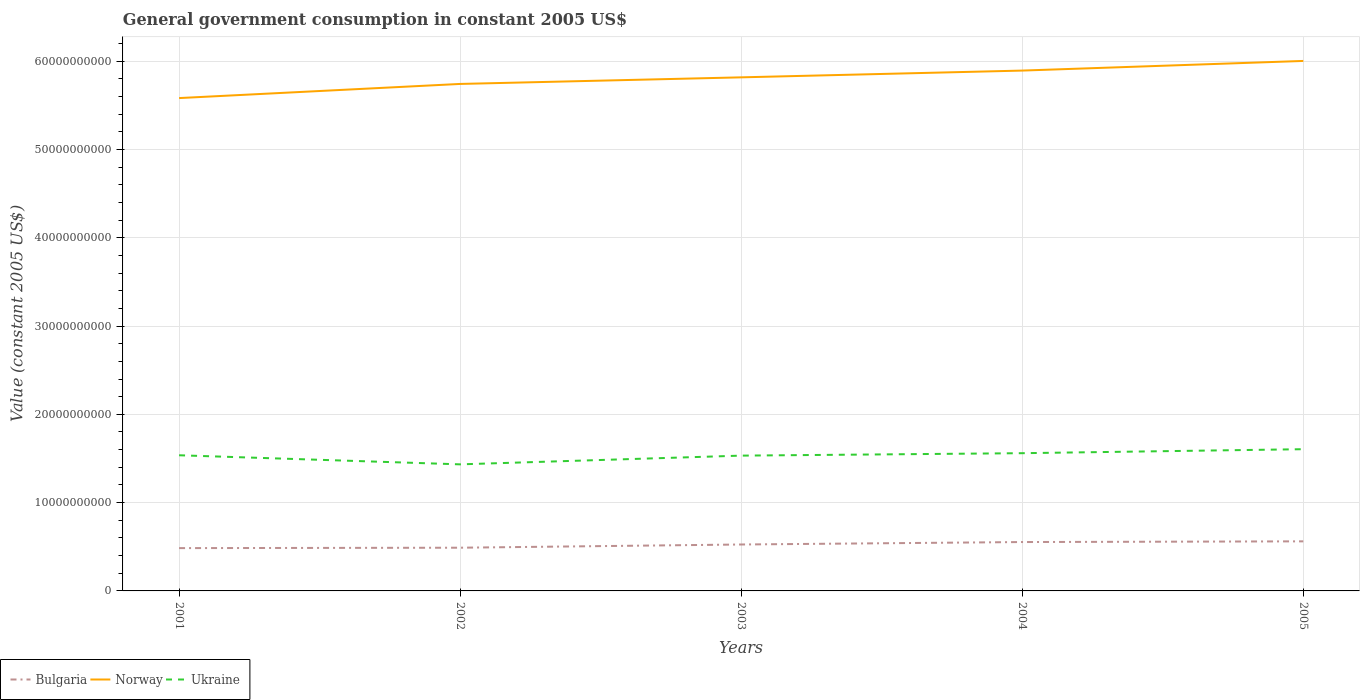How many different coloured lines are there?
Make the answer very short. 3. Does the line corresponding to Norway intersect with the line corresponding to Bulgaria?
Provide a short and direct response. No. Is the number of lines equal to the number of legend labels?
Provide a short and direct response. Yes. Across all years, what is the maximum government conusmption in Bulgaria?
Offer a very short reply. 4.85e+09. In which year was the government conusmption in Norway maximum?
Offer a terse response. 2001. What is the total government conusmption in Bulgaria in the graph?
Provide a succinct answer. -6.42e+08. What is the difference between the highest and the second highest government conusmption in Bulgaria?
Provide a succinct answer. 7.66e+08. What is the difference between the highest and the lowest government conusmption in Ukraine?
Give a very brief answer. 3. Is the government conusmption in Bulgaria strictly greater than the government conusmption in Norway over the years?
Provide a succinct answer. Yes. How many lines are there?
Your response must be concise. 3. How many years are there in the graph?
Give a very brief answer. 5. Are the values on the major ticks of Y-axis written in scientific E-notation?
Offer a very short reply. No. Does the graph contain any zero values?
Provide a short and direct response. No. Does the graph contain grids?
Make the answer very short. Yes. How many legend labels are there?
Your answer should be very brief. 3. What is the title of the graph?
Provide a succinct answer. General government consumption in constant 2005 US$. What is the label or title of the Y-axis?
Provide a short and direct response. Value (constant 2005 US$). What is the Value (constant 2005 US$) in Bulgaria in 2001?
Offer a very short reply. 4.85e+09. What is the Value (constant 2005 US$) in Norway in 2001?
Offer a terse response. 5.58e+1. What is the Value (constant 2005 US$) of Ukraine in 2001?
Provide a short and direct response. 1.54e+1. What is the Value (constant 2005 US$) of Bulgaria in 2002?
Your answer should be compact. 4.89e+09. What is the Value (constant 2005 US$) of Norway in 2002?
Make the answer very short. 5.74e+1. What is the Value (constant 2005 US$) of Ukraine in 2002?
Make the answer very short. 1.43e+1. What is the Value (constant 2005 US$) of Bulgaria in 2003?
Offer a very short reply. 5.26e+09. What is the Value (constant 2005 US$) in Norway in 2003?
Give a very brief answer. 5.82e+1. What is the Value (constant 2005 US$) in Ukraine in 2003?
Your answer should be very brief. 1.53e+1. What is the Value (constant 2005 US$) of Bulgaria in 2004?
Provide a succinct answer. 5.54e+09. What is the Value (constant 2005 US$) in Norway in 2004?
Provide a short and direct response. 5.89e+1. What is the Value (constant 2005 US$) of Ukraine in 2004?
Give a very brief answer. 1.56e+1. What is the Value (constant 2005 US$) of Bulgaria in 2005?
Provide a succinct answer. 5.61e+09. What is the Value (constant 2005 US$) of Norway in 2005?
Offer a very short reply. 6.00e+1. What is the Value (constant 2005 US$) in Ukraine in 2005?
Give a very brief answer. 1.61e+1. Across all years, what is the maximum Value (constant 2005 US$) in Bulgaria?
Ensure brevity in your answer.  5.61e+09. Across all years, what is the maximum Value (constant 2005 US$) of Norway?
Offer a terse response. 6.00e+1. Across all years, what is the maximum Value (constant 2005 US$) in Ukraine?
Ensure brevity in your answer.  1.61e+1. Across all years, what is the minimum Value (constant 2005 US$) in Bulgaria?
Offer a very short reply. 4.85e+09. Across all years, what is the minimum Value (constant 2005 US$) in Norway?
Provide a short and direct response. 5.58e+1. Across all years, what is the minimum Value (constant 2005 US$) in Ukraine?
Provide a short and direct response. 1.43e+1. What is the total Value (constant 2005 US$) of Bulgaria in the graph?
Provide a short and direct response. 2.62e+1. What is the total Value (constant 2005 US$) in Norway in the graph?
Provide a short and direct response. 2.90e+11. What is the total Value (constant 2005 US$) in Ukraine in the graph?
Make the answer very short. 7.67e+1. What is the difference between the Value (constant 2005 US$) of Bulgaria in 2001 and that in 2002?
Your response must be concise. -4.58e+07. What is the difference between the Value (constant 2005 US$) in Norway in 2001 and that in 2002?
Offer a terse response. -1.60e+09. What is the difference between the Value (constant 2005 US$) in Ukraine in 2001 and that in 2002?
Make the answer very short. 1.03e+09. What is the difference between the Value (constant 2005 US$) of Bulgaria in 2001 and that in 2003?
Your answer should be very brief. -4.10e+08. What is the difference between the Value (constant 2005 US$) in Norway in 2001 and that in 2003?
Offer a terse response. -2.35e+09. What is the difference between the Value (constant 2005 US$) in Ukraine in 2001 and that in 2003?
Offer a terse response. 4.03e+07. What is the difference between the Value (constant 2005 US$) of Bulgaria in 2001 and that in 2004?
Give a very brief answer. -6.88e+08. What is the difference between the Value (constant 2005 US$) of Norway in 2001 and that in 2004?
Offer a terse response. -3.11e+09. What is the difference between the Value (constant 2005 US$) of Ukraine in 2001 and that in 2004?
Your answer should be compact. -2.36e+08. What is the difference between the Value (constant 2005 US$) in Bulgaria in 2001 and that in 2005?
Ensure brevity in your answer.  -7.66e+08. What is the difference between the Value (constant 2005 US$) in Norway in 2001 and that in 2005?
Offer a terse response. -4.21e+09. What is the difference between the Value (constant 2005 US$) in Ukraine in 2001 and that in 2005?
Offer a very short reply. -6.88e+08. What is the difference between the Value (constant 2005 US$) in Bulgaria in 2002 and that in 2003?
Provide a short and direct response. -3.64e+08. What is the difference between the Value (constant 2005 US$) of Norway in 2002 and that in 2003?
Keep it short and to the point. -7.47e+08. What is the difference between the Value (constant 2005 US$) in Ukraine in 2002 and that in 2003?
Offer a very short reply. -9.89e+08. What is the difference between the Value (constant 2005 US$) in Bulgaria in 2002 and that in 2004?
Provide a short and direct response. -6.42e+08. What is the difference between the Value (constant 2005 US$) of Norway in 2002 and that in 2004?
Your answer should be compact. -1.51e+09. What is the difference between the Value (constant 2005 US$) of Ukraine in 2002 and that in 2004?
Offer a very short reply. -1.26e+09. What is the difference between the Value (constant 2005 US$) of Bulgaria in 2002 and that in 2005?
Give a very brief answer. -7.21e+08. What is the difference between the Value (constant 2005 US$) of Norway in 2002 and that in 2005?
Ensure brevity in your answer.  -2.61e+09. What is the difference between the Value (constant 2005 US$) of Ukraine in 2002 and that in 2005?
Ensure brevity in your answer.  -1.72e+09. What is the difference between the Value (constant 2005 US$) of Bulgaria in 2003 and that in 2004?
Keep it short and to the point. -2.78e+08. What is the difference between the Value (constant 2005 US$) in Norway in 2003 and that in 2004?
Give a very brief answer. -7.66e+08. What is the difference between the Value (constant 2005 US$) of Ukraine in 2003 and that in 2004?
Offer a terse response. -2.76e+08. What is the difference between the Value (constant 2005 US$) of Bulgaria in 2003 and that in 2005?
Provide a succinct answer. -3.56e+08. What is the difference between the Value (constant 2005 US$) of Norway in 2003 and that in 2005?
Offer a terse response. -1.86e+09. What is the difference between the Value (constant 2005 US$) of Ukraine in 2003 and that in 2005?
Your answer should be compact. -7.28e+08. What is the difference between the Value (constant 2005 US$) in Bulgaria in 2004 and that in 2005?
Make the answer very short. -7.82e+07. What is the difference between the Value (constant 2005 US$) of Norway in 2004 and that in 2005?
Your answer should be very brief. -1.09e+09. What is the difference between the Value (constant 2005 US$) in Ukraine in 2004 and that in 2005?
Offer a very short reply. -4.52e+08. What is the difference between the Value (constant 2005 US$) of Bulgaria in 2001 and the Value (constant 2005 US$) of Norway in 2002?
Offer a very short reply. -5.26e+1. What is the difference between the Value (constant 2005 US$) of Bulgaria in 2001 and the Value (constant 2005 US$) of Ukraine in 2002?
Provide a succinct answer. -9.49e+09. What is the difference between the Value (constant 2005 US$) in Norway in 2001 and the Value (constant 2005 US$) in Ukraine in 2002?
Provide a succinct answer. 4.15e+1. What is the difference between the Value (constant 2005 US$) of Bulgaria in 2001 and the Value (constant 2005 US$) of Norway in 2003?
Your answer should be compact. -5.33e+1. What is the difference between the Value (constant 2005 US$) in Bulgaria in 2001 and the Value (constant 2005 US$) in Ukraine in 2003?
Ensure brevity in your answer.  -1.05e+1. What is the difference between the Value (constant 2005 US$) of Norway in 2001 and the Value (constant 2005 US$) of Ukraine in 2003?
Your answer should be compact. 4.05e+1. What is the difference between the Value (constant 2005 US$) of Bulgaria in 2001 and the Value (constant 2005 US$) of Norway in 2004?
Offer a very short reply. -5.41e+1. What is the difference between the Value (constant 2005 US$) in Bulgaria in 2001 and the Value (constant 2005 US$) in Ukraine in 2004?
Offer a very short reply. -1.08e+1. What is the difference between the Value (constant 2005 US$) of Norway in 2001 and the Value (constant 2005 US$) of Ukraine in 2004?
Offer a terse response. 4.02e+1. What is the difference between the Value (constant 2005 US$) in Bulgaria in 2001 and the Value (constant 2005 US$) in Norway in 2005?
Your response must be concise. -5.52e+1. What is the difference between the Value (constant 2005 US$) in Bulgaria in 2001 and the Value (constant 2005 US$) in Ukraine in 2005?
Your response must be concise. -1.12e+1. What is the difference between the Value (constant 2005 US$) in Norway in 2001 and the Value (constant 2005 US$) in Ukraine in 2005?
Ensure brevity in your answer.  3.98e+1. What is the difference between the Value (constant 2005 US$) of Bulgaria in 2002 and the Value (constant 2005 US$) of Norway in 2003?
Make the answer very short. -5.33e+1. What is the difference between the Value (constant 2005 US$) of Bulgaria in 2002 and the Value (constant 2005 US$) of Ukraine in 2003?
Offer a terse response. -1.04e+1. What is the difference between the Value (constant 2005 US$) of Norway in 2002 and the Value (constant 2005 US$) of Ukraine in 2003?
Your response must be concise. 4.21e+1. What is the difference between the Value (constant 2005 US$) in Bulgaria in 2002 and the Value (constant 2005 US$) in Norway in 2004?
Provide a short and direct response. -5.40e+1. What is the difference between the Value (constant 2005 US$) in Bulgaria in 2002 and the Value (constant 2005 US$) in Ukraine in 2004?
Your answer should be compact. -1.07e+1. What is the difference between the Value (constant 2005 US$) of Norway in 2002 and the Value (constant 2005 US$) of Ukraine in 2004?
Provide a succinct answer. 4.18e+1. What is the difference between the Value (constant 2005 US$) in Bulgaria in 2002 and the Value (constant 2005 US$) in Norway in 2005?
Provide a short and direct response. -5.51e+1. What is the difference between the Value (constant 2005 US$) in Bulgaria in 2002 and the Value (constant 2005 US$) in Ukraine in 2005?
Your response must be concise. -1.12e+1. What is the difference between the Value (constant 2005 US$) of Norway in 2002 and the Value (constant 2005 US$) of Ukraine in 2005?
Your answer should be compact. 4.14e+1. What is the difference between the Value (constant 2005 US$) in Bulgaria in 2003 and the Value (constant 2005 US$) in Norway in 2004?
Ensure brevity in your answer.  -5.37e+1. What is the difference between the Value (constant 2005 US$) of Bulgaria in 2003 and the Value (constant 2005 US$) of Ukraine in 2004?
Ensure brevity in your answer.  -1.03e+1. What is the difference between the Value (constant 2005 US$) of Norway in 2003 and the Value (constant 2005 US$) of Ukraine in 2004?
Your answer should be very brief. 4.26e+1. What is the difference between the Value (constant 2005 US$) of Bulgaria in 2003 and the Value (constant 2005 US$) of Norway in 2005?
Offer a terse response. -5.48e+1. What is the difference between the Value (constant 2005 US$) of Bulgaria in 2003 and the Value (constant 2005 US$) of Ukraine in 2005?
Offer a terse response. -1.08e+1. What is the difference between the Value (constant 2005 US$) of Norway in 2003 and the Value (constant 2005 US$) of Ukraine in 2005?
Your answer should be compact. 4.21e+1. What is the difference between the Value (constant 2005 US$) in Bulgaria in 2004 and the Value (constant 2005 US$) in Norway in 2005?
Ensure brevity in your answer.  -5.45e+1. What is the difference between the Value (constant 2005 US$) of Bulgaria in 2004 and the Value (constant 2005 US$) of Ukraine in 2005?
Give a very brief answer. -1.05e+1. What is the difference between the Value (constant 2005 US$) in Norway in 2004 and the Value (constant 2005 US$) in Ukraine in 2005?
Provide a succinct answer. 4.29e+1. What is the average Value (constant 2005 US$) of Bulgaria per year?
Provide a succinct answer. 5.23e+09. What is the average Value (constant 2005 US$) of Norway per year?
Provide a succinct answer. 5.81e+1. What is the average Value (constant 2005 US$) in Ukraine per year?
Provide a short and direct response. 1.53e+1. In the year 2001, what is the difference between the Value (constant 2005 US$) of Bulgaria and Value (constant 2005 US$) of Norway?
Keep it short and to the point. -5.10e+1. In the year 2001, what is the difference between the Value (constant 2005 US$) of Bulgaria and Value (constant 2005 US$) of Ukraine?
Make the answer very short. -1.05e+1. In the year 2001, what is the difference between the Value (constant 2005 US$) of Norway and Value (constant 2005 US$) of Ukraine?
Offer a terse response. 4.05e+1. In the year 2002, what is the difference between the Value (constant 2005 US$) of Bulgaria and Value (constant 2005 US$) of Norway?
Offer a very short reply. -5.25e+1. In the year 2002, what is the difference between the Value (constant 2005 US$) in Bulgaria and Value (constant 2005 US$) in Ukraine?
Your answer should be compact. -9.44e+09. In the year 2002, what is the difference between the Value (constant 2005 US$) of Norway and Value (constant 2005 US$) of Ukraine?
Provide a succinct answer. 4.31e+1. In the year 2003, what is the difference between the Value (constant 2005 US$) in Bulgaria and Value (constant 2005 US$) in Norway?
Ensure brevity in your answer.  -5.29e+1. In the year 2003, what is the difference between the Value (constant 2005 US$) in Bulgaria and Value (constant 2005 US$) in Ukraine?
Provide a succinct answer. -1.01e+1. In the year 2003, what is the difference between the Value (constant 2005 US$) of Norway and Value (constant 2005 US$) of Ukraine?
Ensure brevity in your answer.  4.28e+1. In the year 2004, what is the difference between the Value (constant 2005 US$) in Bulgaria and Value (constant 2005 US$) in Norway?
Your answer should be compact. -5.34e+1. In the year 2004, what is the difference between the Value (constant 2005 US$) of Bulgaria and Value (constant 2005 US$) of Ukraine?
Offer a terse response. -1.01e+1. In the year 2004, what is the difference between the Value (constant 2005 US$) in Norway and Value (constant 2005 US$) in Ukraine?
Provide a succinct answer. 4.33e+1. In the year 2005, what is the difference between the Value (constant 2005 US$) of Bulgaria and Value (constant 2005 US$) of Norway?
Ensure brevity in your answer.  -5.44e+1. In the year 2005, what is the difference between the Value (constant 2005 US$) of Bulgaria and Value (constant 2005 US$) of Ukraine?
Give a very brief answer. -1.04e+1. In the year 2005, what is the difference between the Value (constant 2005 US$) of Norway and Value (constant 2005 US$) of Ukraine?
Your answer should be compact. 4.40e+1. What is the ratio of the Value (constant 2005 US$) of Bulgaria in 2001 to that in 2002?
Your answer should be very brief. 0.99. What is the ratio of the Value (constant 2005 US$) in Norway in 2001 to that in 2002?
Provide a succinct answer. 0.97. What is the ratio of the Value (constant 2005 US$) in Ukraine in 2001 to that in 2002?
Offer a terse response. 1.07. What is the ratio of the Value (constant 2005 US$) of Bulgaria in 2001 to that in 2003?
Make the answer very short. 0.92. What is the ratio of the Value (constant 2005 US$) in Norway in 2001 to that in 2003?
Your answer should be very brief. 0.96. What is the ratio of the Value (constant 2005 US$) of Bulgaria in 2001 to that in 2004?
Give a very brief answer. 0.88. What is the ratio of the Value (constant 2005 US$) of Norway in 2001 to that in 2004?
Keep it short and to the point. 0.95. What is the ratio of the Value (constant 2005 US$) in Ukraine in 2001 to that in 2004?
Give a very brief answer. 0.98. What is the ratio of the Value (constant 2005 US$) of Bulgaria in 2001 to that in 2005?
Give a very brief answer. 0.86. What is the ratio of the Value (constant 2005 US$) in Norway in 2001 to that in 2005?
Ensure brevity in your answer.  0.93. What is the ratio of the Value (constant 2005 US$) in Ukraine in 2001 to that in 2005?
Your answer should be compact. 0.96. What is the ratio of the Value (constant 2005 US$) in Bulgaria in 2002 to that in 2003?
Your answer should be very brief. 0.93. What is the ratio of the Value (constant 2005 US$) in Norway in 2002 to that in 2003?
Ensure brevity in your answer.  0.99. What is the ratio of the Value (constant 2005 US$) of Ukraine in 2002 to that in 2003?
Offer a very short reply. 0.94. What is the ratio of the Value (constant 2005 US$) of Bulgaria in 2002 to that in 2004?
Keep it short and to the point. 0.88. What is the ratio of the Value (constant 2005 US$) of Norway in 2002 to that in 2004?
Ensure brevity in your answer.  0.97. What is the ratio of the Value (constant 2005 US$) of Ukraine in 2002 to that in 2004?
Keep it short and to the point. 0.92. What is the ratio of the Value (constant 2005 US$) of Bulgaria in 2002 to that in 2005?
Offer a very short reply. 0.87. What is the ratio of the Value (constant 2005 US$) of Norway in 2002 to that in 2005?
Your answer should be very brief. 0.96. What is the ratio of the Value (constant 2005 US$) in Ukraine in 2002 to that in 2005?
Your answer should be compact. 0.89. What is the ratio of the Value (constant 2005 US$) in Bulgaria in 2003 to that in 2004?
Provide a short and direct response. 0.95. What is the ratio of the Value (constant 2005 US$) in Norway in 2003 to that in 2004?
Make the answer very short. 0.99. What is the ratio of the Value (constant 2005 US$) of Ukraine in 2003 to that in 2004?
Provide a short and direct response. 0.98. What is the ratio of the Value (constant 2005 US$) in Bulgaria in 2003 to that in 2005?
Offer a very short reply. 0.94. What is the ratio of the Value (constant 2005 US$) in Norway in 2003 to that in 2005?
Give a very brief answer. 0.97. What is the ratio of the Value (constant 2005 US$) of Ukraine in 2003 to that in 2005?
Provide a short and direct response. 0.95. What is the ratio of the Value (constant 2005 US$) of Bulgaria in 2004 to that in 2005?
Provide a short and direct response. 0.99. What is the ratio of the Value (constant 2005 US$) of Norway in 2004 to that in 2005?
Ensure brevity in your answer.  0.98. What is the ratio of the Value (constant 2005 US$) in Ukraine in 2004 to that in 2005?
Keep it short and to the point. 0.97. What is the difference between the highest and the second highest Value (constant 2005 US$) of Bulgaria?
Provide a succinct answer. 7.82e+07. What is the difference between the highest and the second highest Value (constant 2005 US$) in Norway?
Ensure brevity in your answer.  1.09e+09. What is the difference between the highest and the second highest Value (constant 2005 US$) of Ukraine?
Give a very brief answer. 4.52e+08. What is the difference between the highest and the lowest Value (constant 2005 US$) in Bulgaria?
Offer a very short reply. 7.66e+08. What is the difference between the highest and the lowest Value (constant 2005 US$) of Norway?
Ensure brevity in your answer.  4.21e+09. What is the difference between the highest and the lowest Value (constant 2005 US$) in Ukraine?
Keep it short and to the point. 1.72e+09. 